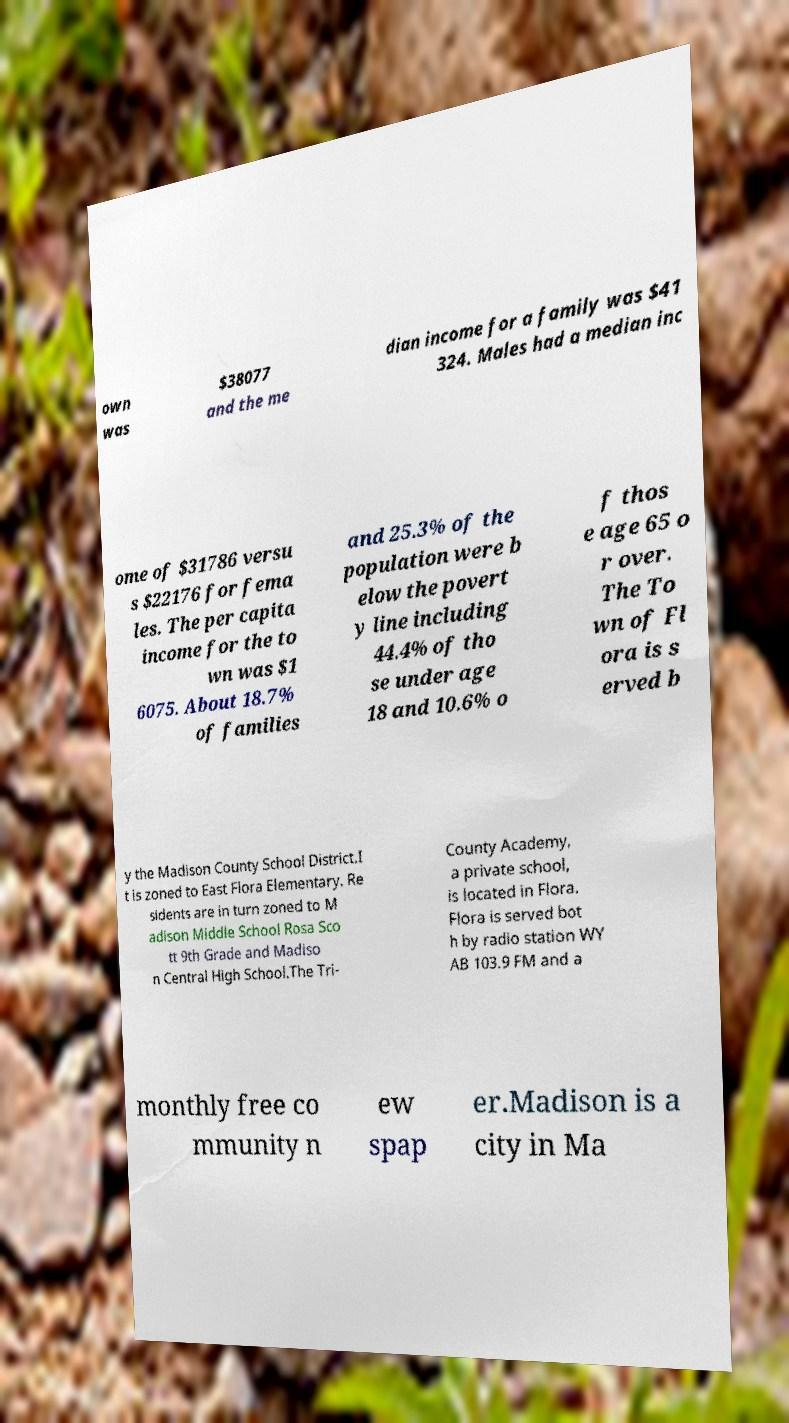Can you accurately transcribe the text from the provided image for me? own was $38077 and the me dian income for a family was $41 324. Males had a median inc ome of $31786 versu s $22176 for fema les. The per capita income for the to wn was $1 6075. About 18.7% of families and 25.3% of the population were b elow the povert y line including 44.4% of tho se under age 18 and 10.6% o f thos e age 65 o r over. The To wn of Fl ora is s erved b y the Madison County School District.I t is zoned to East Flora Elementary. Re sidents are in turn zoned to M adison Middle School Rosa Sco tt 9th Grade and Madiso n Central High School.The Tri- County Academy, a private school, is located in Flora. Flora is served bot h by radio station WY AB 103.9 FM and a monthly free co mmunity n ew spap er.Madison is a city in Ma 